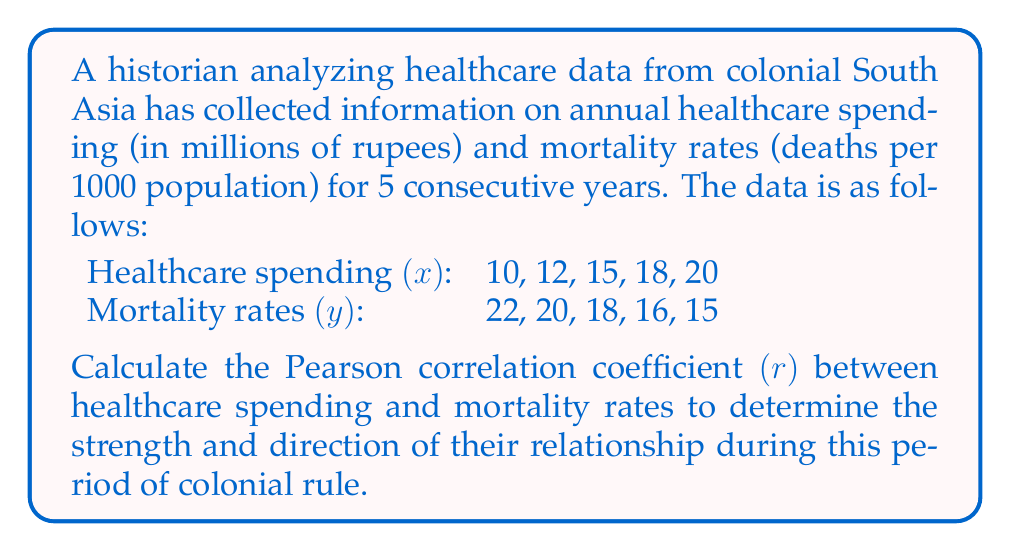Solve this math problem. To calculate the Pearson correlation coefficient (r), we'll follow these steps:

1. Calculate the means of x and y:
   $\bar{x} = \frac{10 + 12 + 15 + 18 + 20}{5} = 15$
   $\bar{y} = \frac{22 + 20 + 18 + 16 + 15}{5} = 18.2$

2. Calculate the deviations from the mean:
   x deviations: -5, -3, 0, 3, 5
   y deviations: 3.8, 1.8, -0.2, -2.2, -3.2

3. Calculate the products of the deviations:
   (-5)(3.8), (-3)(1.8), (0)(-0.2), (3)(-2.2), (5)(-3.2)

4. Sum the products of deviations:
   $\sum(x - \bar{x})(y - \bar{y}) = -19 - 5.4 + 0 - 6.6 - 16 = -47$

5. Calculate the sum of squared deviations for x and y:
   $\sum(x - \bar{x})^2 = 25 + 9 + 0 + 9 + 25 = 68$
   $\sum(y - \bar{y})^2 = 14.44 + 3.24 + 0.04 + 4.84 + 10.24 = 32.8$

6. Apply the formula for Pearson correlation coefficient:

   $$r = \frac{\sum(x - \bar{x})(y - \bar{y})}{\sqrt{\sum(x - \bar{x})^2 \sum(y - \bar{y})^2}}$$

   $$r = \frac{-47}{\sqrt{68 \times 32.8}} = \frac{-47}{\sqrt{2230.4}} = \frac{-47}{47.23} = -0.995$$

The correlation coefficient is approximately -0.995, indicating a very strong negative correlation between healthcare spending and mortality rates during this period of colonial rule.
Answer: $r \approx -0.995$ 